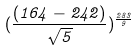Convert formula to latex. <formula><loc_0><loc_0><loc_500><loc_500>( \frac { ( 1 6 4 - 2 4 2 ) } { \sqrt { 5 } } ) ^ { \frac { 2 8 3 } { 9 } }</formula> 